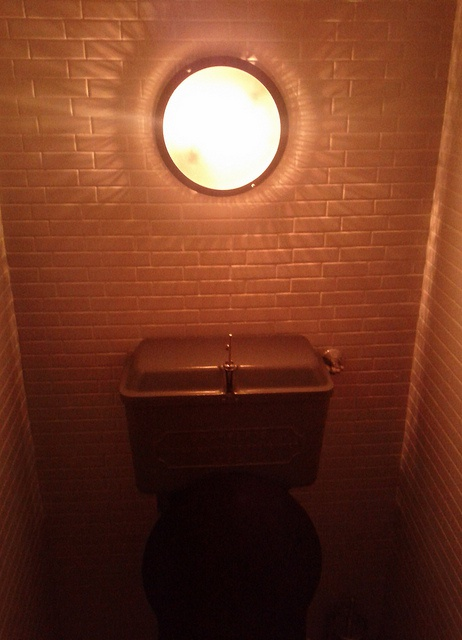Describe the objects in this image and their specific colors. I can see a toilet in maroon, black, and brown tones in this image. 